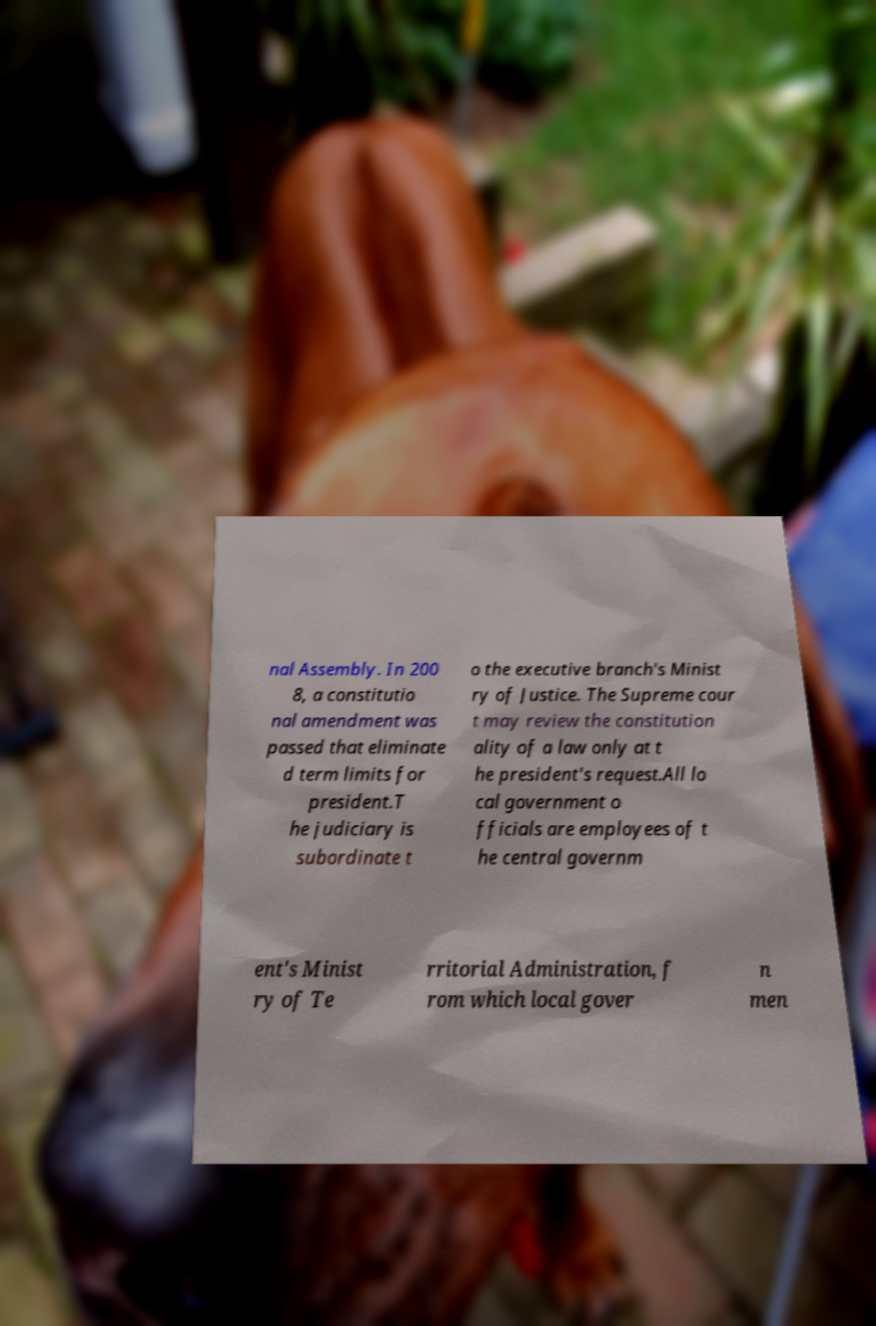Please identify and transcribe the text found in this image. nal Assembly. In 200 8, a constitutio nal amendment was passed that eliminate d term limits for president.T he judiciary is subordinate t o the executive branch's Minist ry of Justice. The Supreme cour t may review the constitution ality of a law only at t he president's request.All lo cal government o fficials are employees of t he central governm ent's Minist ry of Te rritorial Administration, f rom which local gover n men 